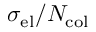Convert formula to latex. <formula><loc_0><loc_0><loc_500><loc_500>\sigma _ { e l } / N _ { c o l }</formula> 